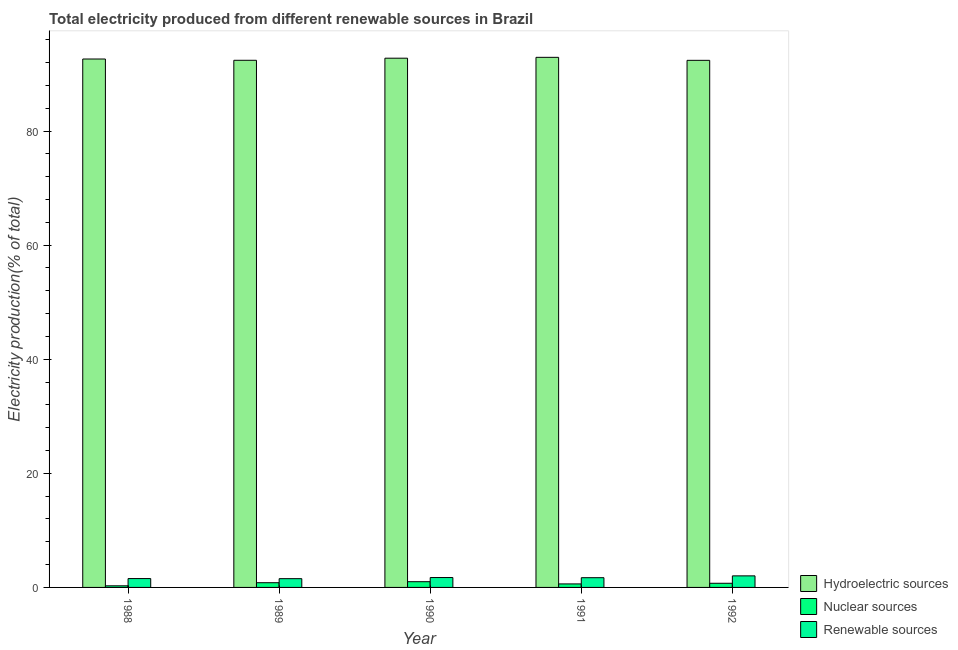Are the number of bars per tick equal to the number of legend labels?
Give a very brief answer. Yes. Are the number of bars on each tick of the X-axis equal?
Offer a terse response. Yes. How many bars are there on the 3rd tick from the left?
Ensure brevity in your answer.  3. In how many cases, is the number of bars for a given year not equal to the number of legend labels?
Make the answer very short. 0. What is the percentage of electricity produced by renewable sources in 1992?
Offer a terse response. 2.03. Across all years, what is the maximum percentage of electricity produced by hydroelectric sources?
Ensure brevity in your answer.  92.92. Across all years, what is the minimum percentage of electricity produced by hydroelectric sources?
Your response must be concise. 92.39. In which year was the percentage of electricity produced by nuclear sources minimum?
Provide a succinct answer. 1988. What is the total percentage of electricity produced by nuclear sources in the graph?
Ensure brevity in your answer.  3.46. What is the difference between the percentage of electricity produced by hydroelectric sources in 1988 and that in 1990?
Offer a very short reply. -0.14. What is the difference between the percentage of electricity produced by renewable sources in 1991 and the percentage of electricity produced by hydroelectric sources in 1992?
Make the answer very short. -0.32. What is the average percentage of electricity produced by hydroelectric sources per year?
Your response must be concise. 92.62. In the year 1990, what is the difference between the percentage of electricity produced by nuclear sources and percentage of electricity produced by renewable sources?
Ensure brevity in your answer.  0. What is the ratio of the percentage of electricity produced by hydroelectric sources in 1988 to that in 1992?
Keep it short and to the point. 1. What is the difference between the highest and the second highest percentage of electricity produced by nuclear sources?
Your answer should be compact. 0.18. What is the difference between the highest and the lowest percentage of electricity produced by renewable sources?
Ensure brevity in your answer.  0.49. In how many years, is the percentage of electricity produced by nuclear sources greater than the average percentage of electricity produced by nuclear sources taken over all years?
Keep it short and to the point. 3. What does the 1st bar from the left in 1988 represents?
Give a very brief answer. Hydroelectric sources. What does the 1st bar from the right in 1992 represents?
Offer a very short reply. Renewable sources. Is it the case that in every year, the sum of the percentage of electricity produced by hydroelectric sources and percentage of electricity produced by nuclear sources is greater than the percentage of electricity produced by renewable sources?
Ensure brevity in your answer.  Yes. How many bars are there?
Make the answer very short. 15. How many years are there in the graph?
Your answer should be very brief. 5. What is the difference between two consecutive major ticks on the Y-axis?
Give a very brief answer. 20. Are the values on the major ticks of Y-axis written in scientific E-notation?
Give a very brief answer. No. Where does the legend appear in the graph?
Give a very brief answer. Bottom right. How are the legend labels stacked?
Keep it short and to the point. Vertical. What is the title of the graph?
Your response must be concise. Total electricity produced from different renewable sources in Brazil. What is the Electricity production(% of total) in Hydroelectric sources in 1988?
Ensure brevity in your answer.  92.62. What is the Electricity production(% of total) in Nuclear sources in 1988?
Your response must be concise. 0.28. What is the Electricity production(% of total) of Renewable sources in 1988?
Offer a very short reply. 1.55. What is the Electricity production(% of total) in Hydroelectric sources in 1989?
Keep it short and to the point. 92.4. What is the Electricity production(% of total) in Nuclear sources in 1989?
Provide a short and direct response. 0.83. What is the Electricity production(% of total) of Renewable sources in 1989?
Ensure brevity in your answer.  1.54. What is the Electricity production(% of total) of Hydroelectric sources in 1990?
Provide a short and direct response. 92.77. What is the Electricity production(% of total) of Nuclear sources in 1990?
Your response must be concise. 1. What is the Electricity production(% of total) in Renewable sources in 1990?
Make the answer very short. 1.73. What is the Electricity production(% of total) in Hydroelectric sources in 1991?
Give a very brief answer. 92.92. What is the Electricity production(% of total) in Nuclear sources in 1991?
Your response must be concise. 0.62. What is the Electricity production(% of total) in Renewable sources in 1991?
Provide a succinct answer. 1.71. What is the Electricity production(% of total) in Hydroelectric sources in 1992?
Give a very brief answer. 92.39. What is the Electricity production(% of total) of Nuclear sources in 1992?
Your answer should be compact. 0.73. What is the Electricity production(% of total) of Renewable sources in 1992?
Give a very brief answer. 2.03. Across all years, what is the maximum Electricity production(% of total) in Hydroelectric sources?
Offer a very short reply. 92.92. Across all years, what is the maximum Electricity production(% of total) in Nuclear sources?
Your answer should be compact. 1. Across all years, what is the maximum Electricity production(% of total) of Renewable sources?
Your answer should be very brief. 2.03. Across all years, what is the minimum Electricity production(% of total) of Hydroelectric sources?
Offer a terse response. 92.39. Across all years, what is the minimum Electricity production(% of total) in Nuclear sources?
Give a very brief answer. 0.28. Across all years, what is the minimum Electricity production(% of total) of Renewable sources?
Give a very brief answer. 1.54. What is the total Electricity production(% of total) of Hydroelectric sources in the graph?
Your answer should be compact. 463.11. What is the total Electricity production(% of total) in Nuclear sources in the graph?
Ensure brevity in your answer.  3.46. What is the total Electricity production(% of total) in Renewable sources in the graph?
Make the answer very short. 8.55. What is the difference between the Electricity production(% of total) of Hydroelectric sources in 1988 and that in 1989?
Your answer should be compact. 0.22. What is the difference between the Electricity production(% of total) of Nuclear sources in 1988 and that in 1989?
Provide a short and direct response. -0.54. What is the difference between the Electricity production(% of total) of Renewable sources in 1988 and that in 1989?
Keep it short and to the point. 0.02. What is the difference between the Electricity production(% of total) in Hydroelectric sources in 1988 and that in 1990?
Provide a short and direct response. -0.14. What is the difference between the Electricity production(% of total) in Nuclear sources in 1988 and that in 1990?
Make the answer very short. -0.72. What is the difference between the Electricity production(% of total) in Renewable sources in 1988 and that in 1990?
Your response must be concise. -0.18. What is the difference between the Electricity production(% of total) in Hydroelectric sources in 1988 and that in 1991?
Ensure brevity in your answer.  -0.3. What is the difference between the Electricity production(% of total) of Nuclear sources in 1988 and that in 1991?
Offer a terse response. -0.33. What is the difference between the Electricity production(% of total) in Renewable sources in 1988 and that in 1991?
Keep it short and to the point. -0.15. What is the difference between the Electricity production(% of total) in Hydroelectric sources in 1988 and that in 1992?
Provide a short and direct response. 0.23. What is the difference between the Electricity production(% of total) in Nuclear sources in 1988 and that in 1992?
Ensure brevity in your answer.  -0.44. What is the difference between the Electricity production(% of total) in Renewable sources in 1988 and that in 1992?
Offer a terse response. -0.47. What is the difference between the Electricity production(% of total) of Hydroelectric sources in 1989 and that in 1990?
Offer a very short reply. -0.37. What is the difference between the Electricity production(% of total) of Nuclear sources in 1989 and that in 1990?
Provide a short and direct response. -0.18. What is the difference between the Electricity production(% of total) in Renewable sources in 1989 and that in 1990?
Provide a short and direct response. -0.2. What is the difference between the Electricity production(% of total) of Hydroelectric sources in 1989 and that in 1991?
Keep it short and to the point. -0.52. What is the difference between the Electricity production(% of total) of Nuclear sources in 1989 and that in 1991?
Your answer should be compact. 0.21. What is the difference between the Electricity production(% of total) in Renewable sources in 1989 and that in 1991?
Your answer should be very brief. -0.17. What is the difference between the Electricity production(% of total) in Hydroelectric sources in 1989 and that in 1992?
Your response must be concise. 0.01. What is the difference between the Electricity production(% of total) of Nuclear sources in 1989 and that in 1992?
Give a very brief answer. 0.1. What is the difference between the Electricity production(% of total) in Renewable sources in 1989 and that in 1992?
Ensure brevity in your answer.  -0.49. What is the difference between the Electricity production(% of total) in Hydroelectric sources in 1990 and that in 1991?
Offer a terse response. -0.15. What is the difference between the Electricity production(% of total) of Nuclear sources in 1990 and that in 1991?
Your answer should be very brief. 0.39. What is the difference between the Electricity production(% of total) in Renewable sources in 1990 and that in 1991?
Offer a terse response. 0.03. What is the difference between the Electricity production(% of total) in Hydroelectric sources in 1990 and that in 1992?
Give a very brief answer. 0.38. What is the difference between the Electricity production(% of total) in Nuclear sources in 1990 and that in 1992?
Your answer should be compact. 0.28. What is the difference between the Electricity production(% of total) in Renewable sources in 1990 and that in 1992?
Keep it short and to the point. -0.29. What is the difference between the Electricity production(% of total) of Hydroelectric sources in 1991 and that in 1992?
Offer a very short reply. 0.53. What is the difference between the Electricity production(% of total) of Nuclear sources in 1991 and that in 1992?
Offer a terse response. -0.11. What is the difference between the Electricity production(% of total) in Renewable sources in 1991 and that in 1992?
Your answer should be compact. -0.32. What is the difference between the Electricity production(% of total) in Hydroelectric sources in 1988 and the Electricity production(% of total) in Nuclear sources in 1989?
Provide a succinct answer. 91.8. What is the difference between the Electricity production(% of total) of Hydroelectric sources in 1988 and the Electricity production(% of total) of Renewable sources in 1989?
Offer a very short reply. 91.09. What is the difference between the Electricity production(% of total) of Nuclear sources in 1988 and the Electricity production(% of total) of Renewable sources in 1989?
Offer a very short reply. -1.25. What is the difference between the Electricity production(% of total) of Hydroelectric sources in 1988 and the Electricity production(% of total) of Nuclear sources in 1990?
Ensure brevity in your answer.  91.62. What is the difference between the Electricity production(% of total) of Hydroelectric sources in 1988 and the Electricity production(% of total) of Renewable sources in 1990?
Provide a succinct answer. 90.89. What is the difference between the Electricity production(% of total) of Nuclear sources in 1988 and the Electricity production(% of total) of Renewable sources in 1990?
Offer a terse response. -1.45. What is the difference between the Electricity production(% of total) of Hydroelectric sources in 1988 and the Electricity production(% of total) of Nuclear sources in 1991?
Offer a terse response. 92.01. What is the difference between the Electricity production(% of total) of Hydroelectric sources in 1988 and the Electricity production(% of total) of Renewable sources in 1991?
Give a very brief answer. 90.92. What is the difference between the Electricity production(% of total) in Nuclear sources in 1988 and the Electricity production(% of total) in Renewable sources in 1991?
Offer a terse response. -1.42. What is the difference between the Electricity production(% of total) of Hydroelectric sources in 1988 and the Electricity production(% of total) of Nuclear sources in 1992?
Your answer should be compact. 91.9. What is the difference between the Electricity production(% of total) of Hydroelectric sources in 1988 and the Electricity production(% of total) of Renewable sources in 1992?
Provide a short and direct response. 90.6. What is the difference between the Electricity production(% of total) of Nuclear sources in 1988 and the Electricity production(% of total) of Renewable sources in 1992?
Your answer should be very brief. -1.74. What is the difference between the Electricity production(% of total) of Hydroelectric sources in 1989 and the Electricity production(% of total) of Nuclear sources in 1990?
Provide a succinct answer. 91.4. What is the difference between the Electricity production(% of total) in Hydroelectric sources in 1989 and the Electricity production(% of total) in Renewable sources in 1990?
Your answer should be very brief. 90.67. What is the difference between the Electricity production(% of total) of Nuclear sources in 1989 and the Electricity production(% of total) of Renewable sources in 1990?
Your answer should be very brief. -0.91. What is the difference between the Electricity production(% of total) in Hydroelectric sources in 1989 and the Electricity production(% of total) in Nuclear sources in 1991?
Your response must be concise. 91.79. What is the difference between the Electricity production(% of total) in Hydroelectric sources in 1989 and the Electricity production(% of total) in Renewable sources in 1991?
Ensure brevity in your answer.  90.69. What is the difference between the Electricity production(% of total) in Nuclear sources in 1989 and the Electricity production(% of total) in Renewable sources in 1991?
Offer a terse response. -0.88. What is the difference between the Electricity production(% of total) of Hydroelectric sources in 1989 and the Electricity production(% of total) of Nuclear sources in 1992?
Your response must be concise. 91.67. What is the difference between the Electricity production(% of total) in Hydroelectric sources in 1989 and the Electricity production(% of total) in Renewable sources in 1992?
Give a very brief answer. 90.37. What is the difference between the Electricity production(% of total) in Nuclear sources in 1989 and the Electricity production(% of total) in Renewable sources in 1992?
Your answer should be very brief. -1.2. What is the difference between the Electricity production(% of total) of Hydroelectric sources in 1990 and the Electricity production(% of total) of Nuclear sources in 1991?
Your answer should be compact. 92.15. What is the difference between the Electricity production(% of total) in Hydroelectric sources in 1990 and the Electricity production(% of total) in Renewable sources in 1991?
Make the answer very short. 91.06. What is the difference between the Electricity production(% of total) in Nuclear sources in 1990 and the Electricity production(% of total) in Renewable sources in 1991?
Offer a very short reply. -0.7. What is the difference between the Electricity production(% of total) in Hydroelectric sources in 1990 and the Electricity production(% of total) in Nuclear sources in 1992?
Keep it short and to the point. 92.04. What is the difference between the Electricity production(% of total) of Hydroelectric sources in 1990 and the Electricity production(% of total) of Renewable sources in 1992?
Keep it short and to the point. 90.74. What is the difference between the Electricity production(% of total) of Nuclear sources in 1990 and the Electricity production(% of total) of Renewable sources in 1992?
Ensure brevity in your answer.  -1.02. What is the difference between the Electricity production(% of total) of Hydroelectric sources in 1991 and the Electricity production(% of total) of Nuclear sources in 1992?
Provide a short and direct response. 92.19. What is the difference between the Electricity production(% of total) in Hydroelectric sources in 1991 and the Electricity production(% of total) in Renewable sources in 1992?
Your response must be concise. 90.89. What is the difference between the Electricity production(% of total) in Nuclear sources in 1991 and the Electricity production(% of total) in Renewable sources in 1992?
Your answer should be compact. -1.41. What is the average Electricity production(% of total) of Hydroelectric sources per year?
Give a very brief answer. 92.62. What is the average Electricity production(% of total) in Nuclear sources per year?
Give a very brief answer. 0.69. What is the average Electricity production(% of total) in Renewable sources per year?
Provide a succinct answer. 1.71. In the year 1988, what is the difference between the Electricity production(% of total) in Hydroelectric sources and Electricity production(% of total) in Nuclear sources?
Offer a very short reply. 92.34. In the year 1988, what is the difference between the Electricity production(% of total) of Hydroelectric sources and Electricity production(% of total) of Renewable sources?
Offer a terse response. 91.07. In the year 1988, what is the difference between the Electricity production(% of total) of Nuclear sources and Electricity production(% of total) of Renewable sources?
Ensure brevity in your answer.  -1.27. In the year 1989, what is the difference between the Electricity production(% of total) of Hydroelectric sources and Electricity production(% of total) of Nuclear sources?
Make the answer very short. 91.58. In the year 1989, what is the difference between the Electricity production(% of total) of Hydroelectric sources and Electricity production(% of total) of Renewable sources?
Provide a succinct answer. 90.87. In the year 1989, what is the difference between the Electricity production(% of total) in Nuclear sources and Electricity production(% of total) in Renewable sources?
Make the answer very short. -0.71. In the year 1990, what is the difference between the Electricity production(% of total) in Hydroelectric sources and Electricity production(% of total) in Nuclear sources?
Ensure brevity in your answer.  91.76. In the year 1990, what is the difference between the Electricity production(% of total) of Hydroelectric sources and Electricity production(% of total) of Renewable sources?
Your answer should be compact. 91.04. In the year 1990, what is the difference between the Electricity production(% of total) in Nuclear sources and Electricity production(% of total) in Renewable sources?
Offer a terse response. -0.73. In the year 1991, what is the difference between the Electricity production(% of total) of Hydroelectric sources and Electricity production(% of total) of Nuclear sources?
Your answer should be compact. 92.3. In the year 1991, what is the difference between the Electricity production(% of total) in Hydroelectric sources and Electricity production(% of total) in Renewable sources?
Keep it short and to the point. 91.21. In the year 1991, what is the difference between the Electricity production(% of total) in Nuclear sources and Electricity production(% of total) in Renewable sources?
Offer a terse response. -1.09. In the year 1992, what is the difference between the Electricity production(% of total) in Hydroelectric sources and Electricity production(% of total) in Nuclear sources?
Your answer should be very brief. 91.67. In the year 1992, what is the difference between the Electricity production(% of total) of Hydroelectric sources and Electricity production(% of total) of Renewable sources?
Your response must be concise. 90.37. In the year 1992, what is the difference between the Electricity production(% of total) of Nuclear sources and Electricity production(% of total) of Renewable sources?
Ensure brevity in your answer.  -1.3. What is the ratio of the Electricity production(% of total) of Nuclear sources in 1988 to that in 1989?
Provide a succinct answer. 0.34. What is the ratio of the Electricity production(% of total) of Renewable sources in 1988 to that in 1989?
Give a very brief answer. 1.01. What is the ratio of the Electricity production(% of total) in Hydroelectric sources in 1988 to that in 1990?
Give a very brief answer. 1. What is the ratio of the Electricity production(% of total) of Nuclear sources in 1988 to that in 1990?
Your answer should be very brief. 0.28. What is the ratio of the Electricity production(% of total) in Renewable sources in 1988 to that in 1990?
Provide a succinct answer. 0.9. What is the ratio of the Electricity production(% of total) in Nuclear sources in 1988 to that in 1991?
Provide a short and direct response. 0.46. What is the ratio of the Electricity production(% of total) of Renewable sources in 1988 to that in 1991?
Your answer should be compact. 0.91. What is the ratio of the Electricity production(% of total) of Hydroelectric sources in 1988 to that in 1992?
Ensure brevity in your answer.  1. What is the ratio of the Electricity production(% of total) in Nuclear sources in 1988 to that in 1992?
Provide a succinct answer. 0.39. What is the ratio of the Electricity production(% of total) in Renewable sources in 1988 to that in 1992?
Offer a terse response. 0.77. What is the ratio of the Electricity production(% of total) in Nuclear sources in 1989 to that in 1990?
Your answer should be compact. 0.82. What is the ratio of the Electricity production(% of total) in Renewable sources in 1989 to that in 1990?
Your answer should be very brief. 0.89. What is the ratio of the Electricity production(% of total) of Nuclear sources in 1989 to that in 1991?
Make the answer very short. 1.34. What is the ratio of the Electricity production(% of total) of Renewable sources in 1989 to that in 1991?
Provide a short and direct response. 0.9. What is the ratio of the Electricity production(% of total) of Nuclear sources in 1989 to that in 1992?
Ensure brevity in your answer.  1.14. What is the ratio of the Electricity production(% of total) in Renewable sources in 1989 to that in 1992?
Ensure brevity in your answer.  0.76. What is the ratio of the Electricity production(% of total) in Nuclear sources in 1990 to that in 1991?
Your answer should be compact. 1.63. What is the ratio of the Electricity production(% of total) in Nuclear sources in 1990 to that in 1992?
Give a very brief answer. 1.38. What is the ratio of the Electricity production(% of total) of Renewable sources in 1990 to that in 1992?
Make the answer very short. 0.85. What is the ratio of the Electricity production(% of total) in Nuclear sources in 1991 to that in 1992?
Offer a very short reply. 0.85. What is the ratio of the Electricity production(% of total) in Renewable sources in 1991 to that in 1992?
Offer a terse response. 0.84. What is the difference between the highest and the second highest Electricity production(% of total) in Hydroelectric sources?
Keep it short and to the point. 0.15. What is the difference between the highest and the second highest Electricity production(% of total) of Nuclear sources?
Offer a terse response. 0.18. What is the difference between the highest and the second highest Electricity production(% of total) in Renewable sources?
Provide a succinct answer. 0.29. What is the difference between the highest and the lowest Electricity production(% of total) in Hydroelectric sources?
Your answer should be very brief. 0.53. What is the difference between the highest and the lowest Electricity production(% of total) of Nuclear sources?
Offer a very short reply. 0.72. What is the difference between the highest and the lowest Electricity production(% of total) in Renewable sources?
Your answer should be compact. 0.49. 